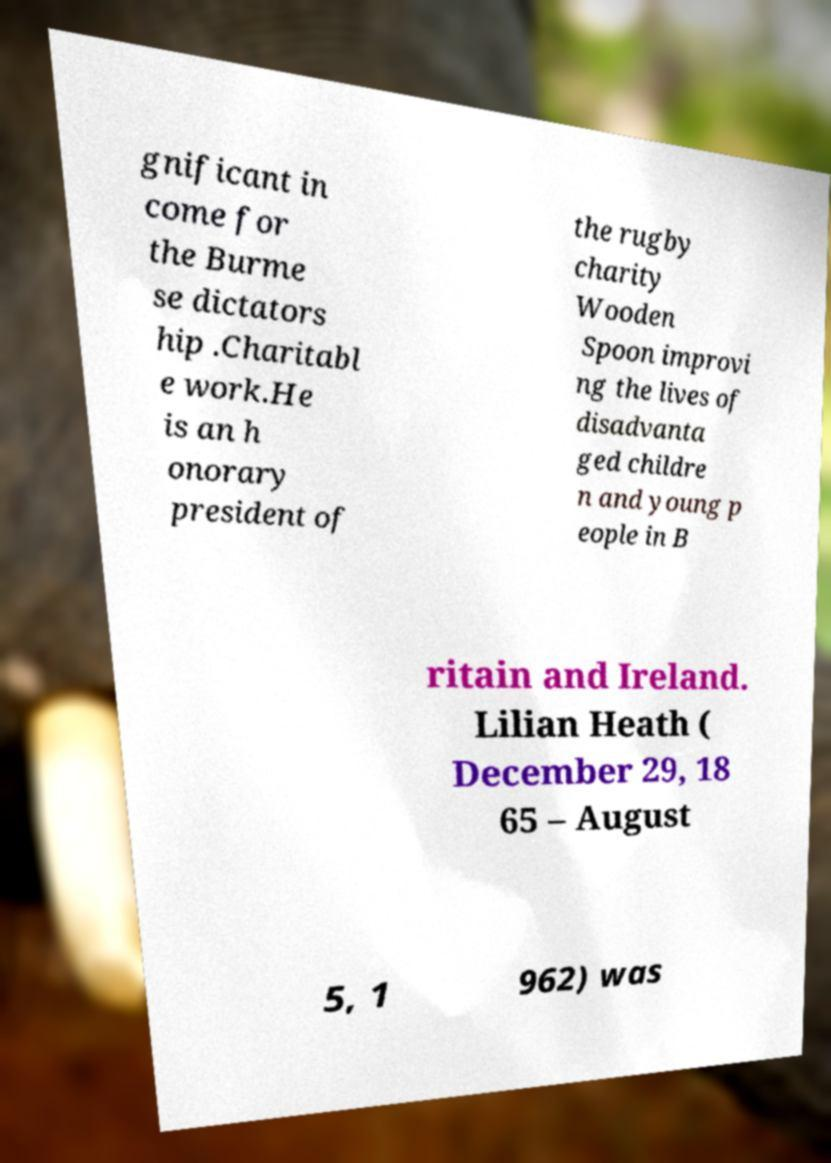For documentation purposes, I need the text within this image transcribed. Could you provide that? gnificant in come for the Burme se dictators hip .Charitabl e work.He is an h onorary president of the rugby charity Wooden Spoon improvi ng the lives of disadvanta ged childre n and young p eople in B ritain and Ireland. Lilian Heath ( December 29, 18 65 – August 5, 1 962) was 